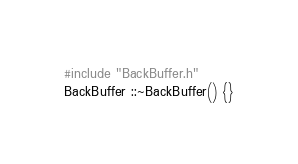Convert code to text. <code><loc_0><loc_0><loc_500><loc_500><_C++_>#include "BackBuffer.h"
BackBuffer ::~BackBuffer() {}
</code> 